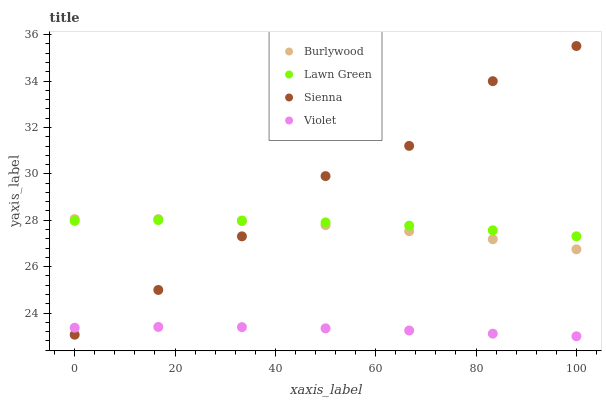Does Violet have the minimum area under the curve?
Answer yes or no. Yes. Does Sienna have the maximum area under the curve?
Answer yes or no. Yes. Does Lawn Green have the minimum area under the curve?
Answer yes or no. No. Does Lawn Green have the maximum area under the curve?
Answer yes or no. No. Is Violet the smoothest?
Answer yes or no. Yes. Is Sienna the roughest?
Answer yes or no. Yes. Is Lawn Green the smoothest?
Answer yes or no. No. Is Lawn Green the roughest?
Answer yes or no. No. Does Violet have the lowest value?
Answer yes or no. Yes. Does Lawn Green have the lowest value?
Answer yes or no. No. Does Sienna have the highest value?
Answer yes or no. Yes. Does Lawn Green have the highest value?
Answer yes or no. No. Is Violet less than Burlywood?
Answer yes or no. Yes. Is Burlywood greater than Violet?
Answer yes or no. Yes. Does Sienna intersect Burlywood?
Answer yes or no. Yes. Is Sienna less than Burlywood?
Answer yes or no. No. Is Sienna greater than Burlywood?
Answer yes or no. No. Does Violet intersect Burlywood?
Answer yes or no. No. 